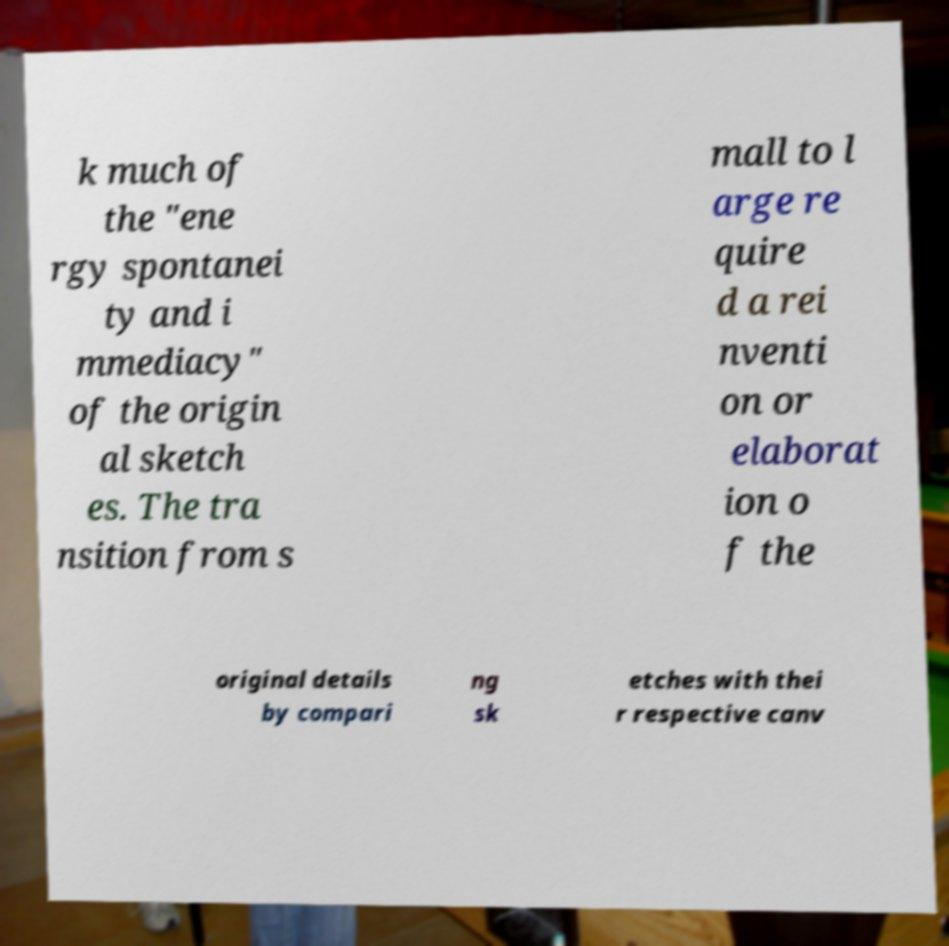I need the written content from this picture converted into text. Can you do that? k much of the "ene rgy spontanei ty and i mmediacy" of the origin al sketch es. The tra nsition from s mall to l arge re quire d a rei nventi on or elaborat ion o f the original details by compari ng sk etches with thei r respective canv 